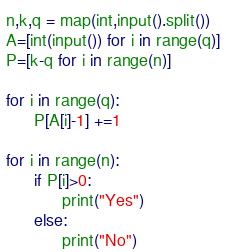Convert code to text. <code><loc_0><loc_0><loc_500><loc_500><_Python_>n,k,q = map(int,input().split())
A=[int(input()) for i in range(q)]
P=[k-q for i in range(n)]

for i in range(q):
      P[A[i]-1] +=1

for i in range(n):
      if P[i]>0:
            print("Yes")
      else:
            print("No")</code> 